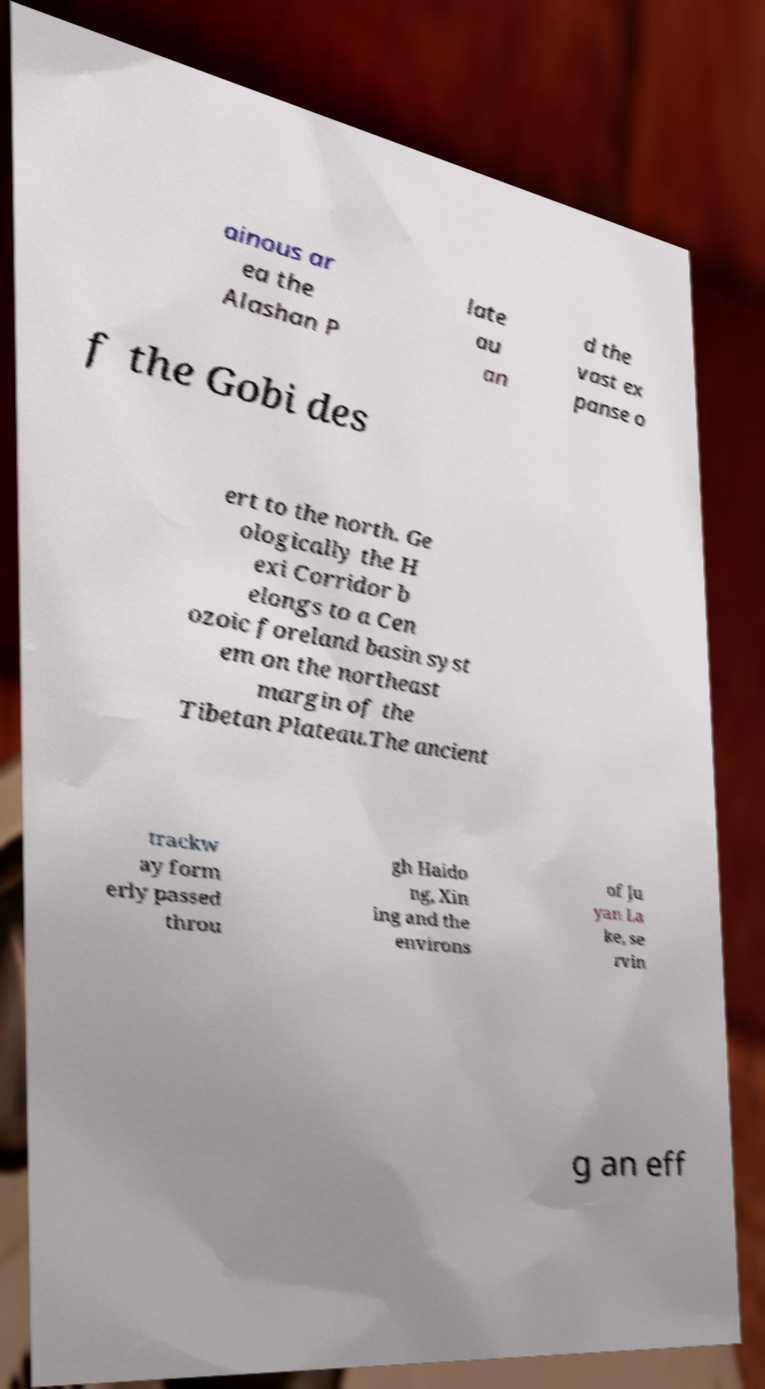For documentation purposes, I need the text within this image transcribed. Could you provide that? ainous ar ea the Alashan P late au an d the vast ex panse o f the Gobi des ert to the north. Ge ologically the H exi Corridor b elongs to a Cen ozoic foreland basin syst em on the northeast margin of the Tibetan Plateau.The ancient trackw ay form erly passed throu gh Haido ng, Xin ing and the environs of Ju yan La ke, se rvin g an eff 